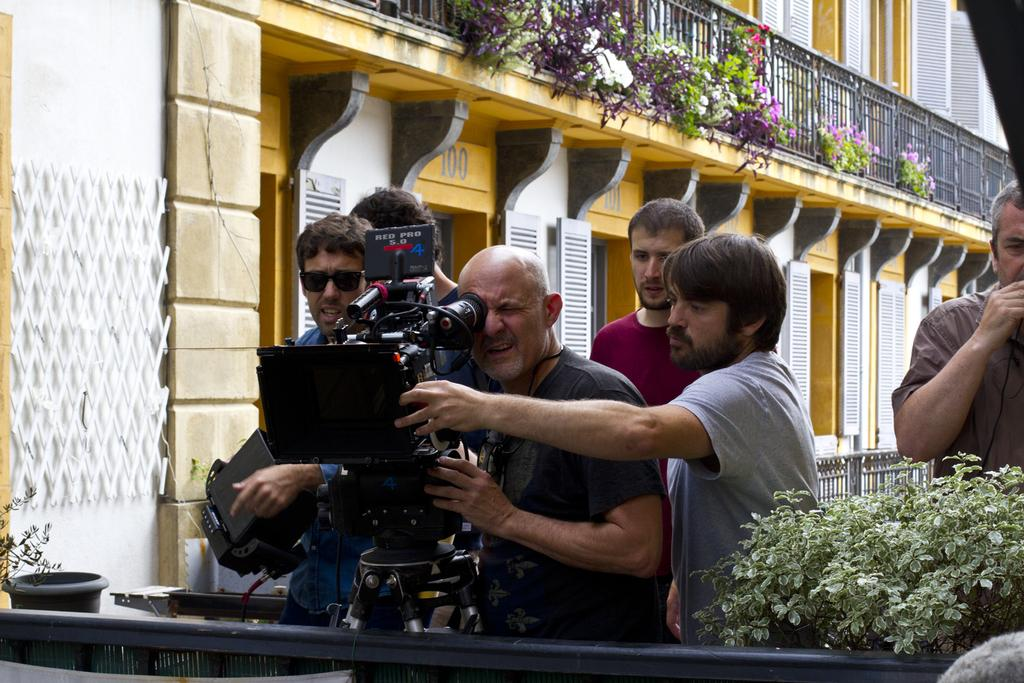What is the primary subject of the image? There are men in the image. Can you describe the positioning of the men in relation to each other? The center man is looking into the camera. What type of vegetation is present in the image? There is a plant beside the men. What can be seen in the distance behind the men? There is a building in the background of the image. What type of veil is covering the top of the building in the image? There is no veil present in the image, and the top of the building is not covered. 